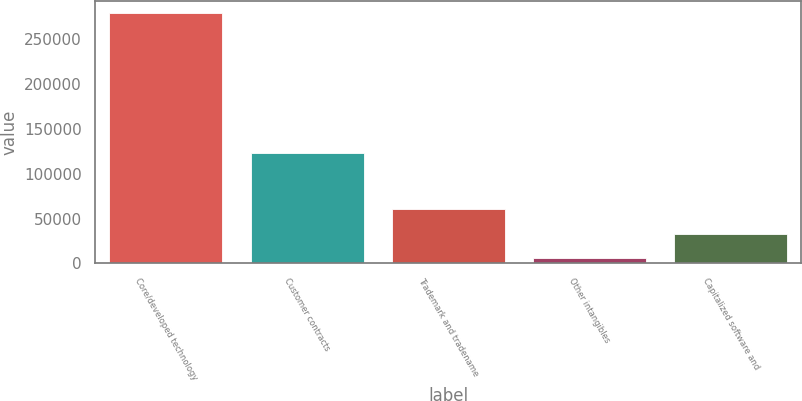<chart> <loc_0><loc_0><loc_500><loc_500><bar_chart><fcel>Core/developed technology<fcel>Customer contracts<fcel>Trademark and tradename<fcel>Other intangibles<fcel>Capitalized software and<nl><fcel>279110<fcel>123540<fcel>60616.4<fcel>5993<fcel>33304.7<nl></chart> 